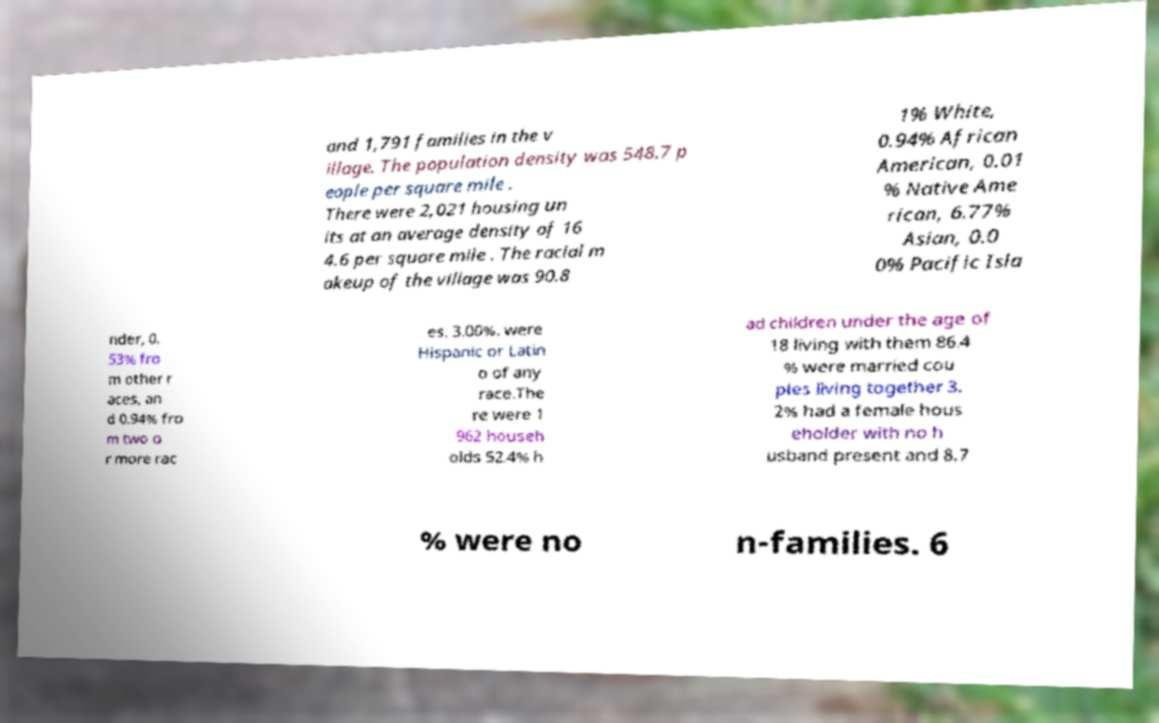I need the written content from this picture converted into text. Can you do that? and 1,791 families in the v illage. The population density was 548.7 p eople per square mile . There were 2,021 housing un its at an average density of 16 4.6 per square mile . The racial m akeup of the village was 90.8 1% White, 0.94% African American, 0.01 % Native Ame rican, 6.77% Asian, 0.0 0% Pacific Isla nder, 0. 53% fro m other r aces, an d 0.94% fro m two o r more rac es. 3.00%. were Hispanic or Latin o of any race.The re were 1 962 househ olds 52.4% h ad children under the age of 18 living with them 86.4 % were married cou ples living together 3. 2% had a female hous eholder with no h usband present and 8.7 % were no n-families. 6 